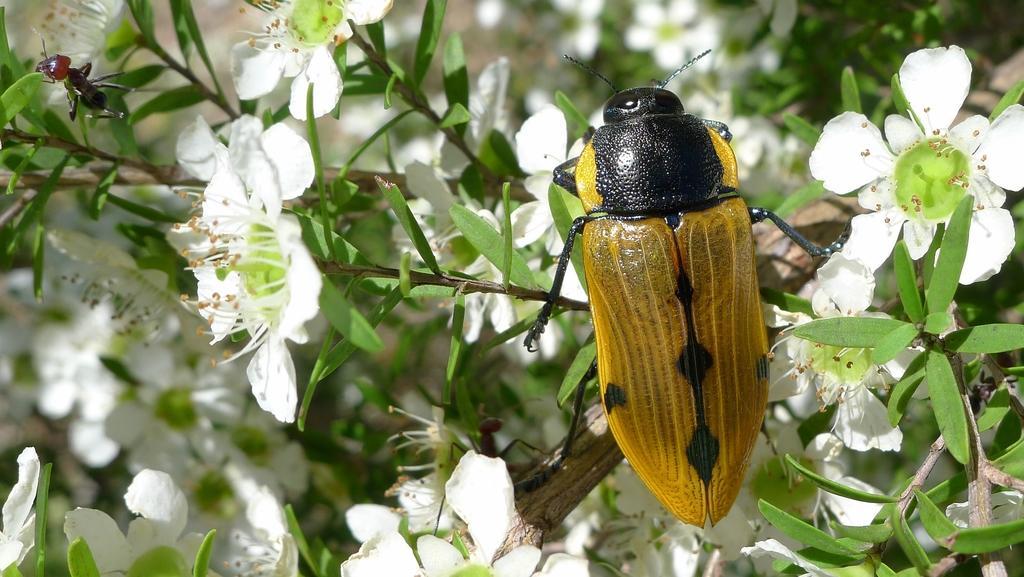Can you describe this image briefly? In this image I see 2 insects in which this one if of red and black in color and this one is of yellow and black in color and I see the green leaves and white flowers on the stems and it is blurred in the background. 